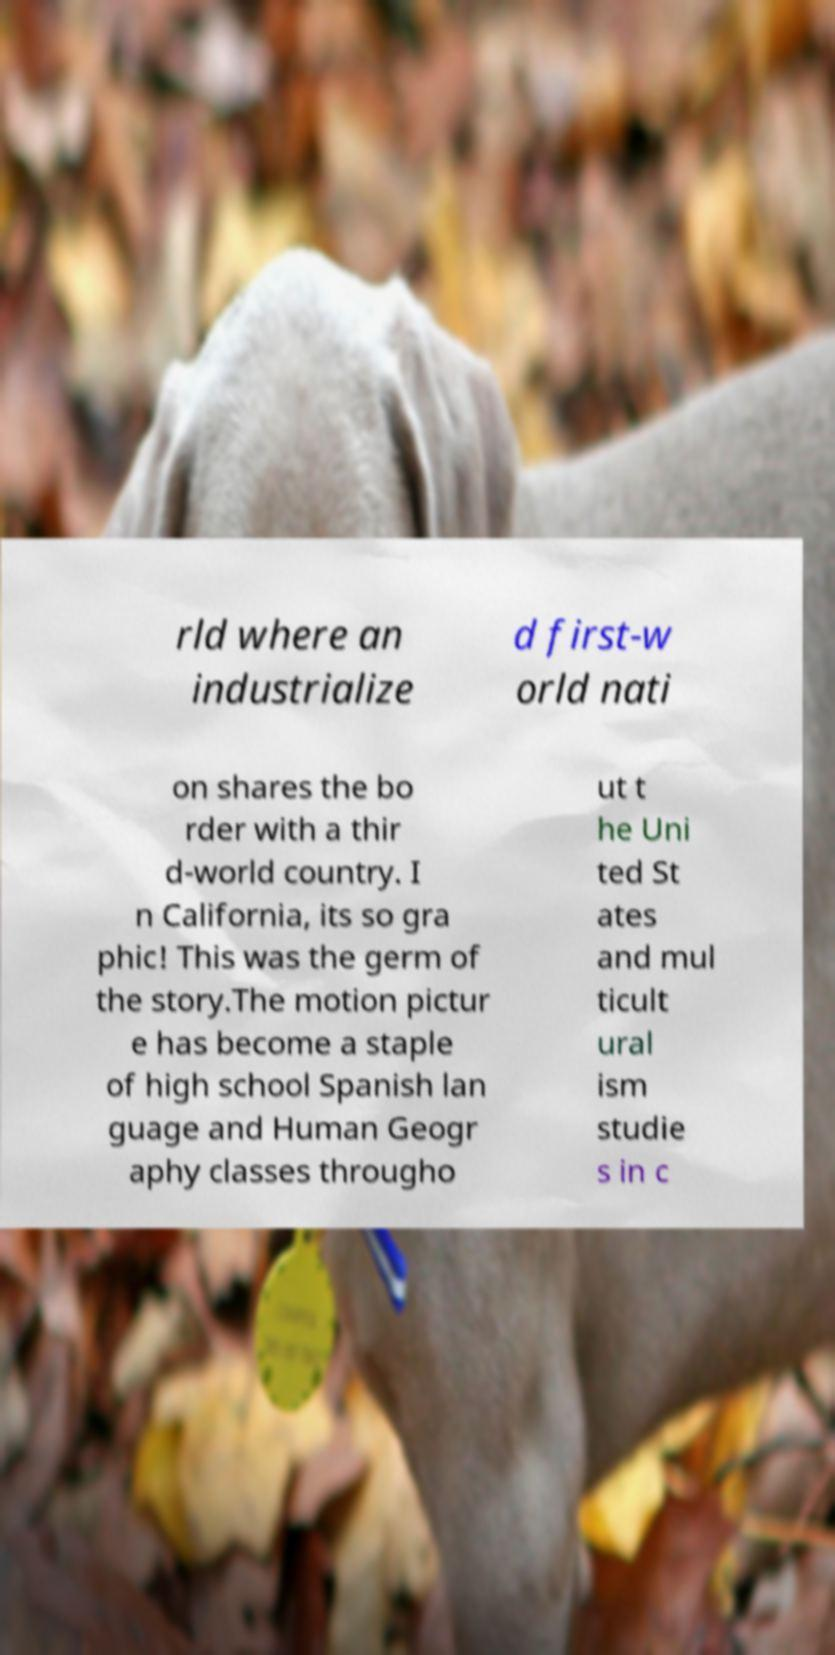There's text embedded in this image that I need extracted. Can you transcribe it verbatim? rld where an industrialize d first-w orld nati on shares the bo rder with a thir d-world country. I n California, its so gra phic! This was the germ of the story.The motion pictur e has become a staple of high school Spanish lan guage and Human Geogr aphy classes througho ut t he Uni ted St ates and mul ticult ural ism studie s in c 